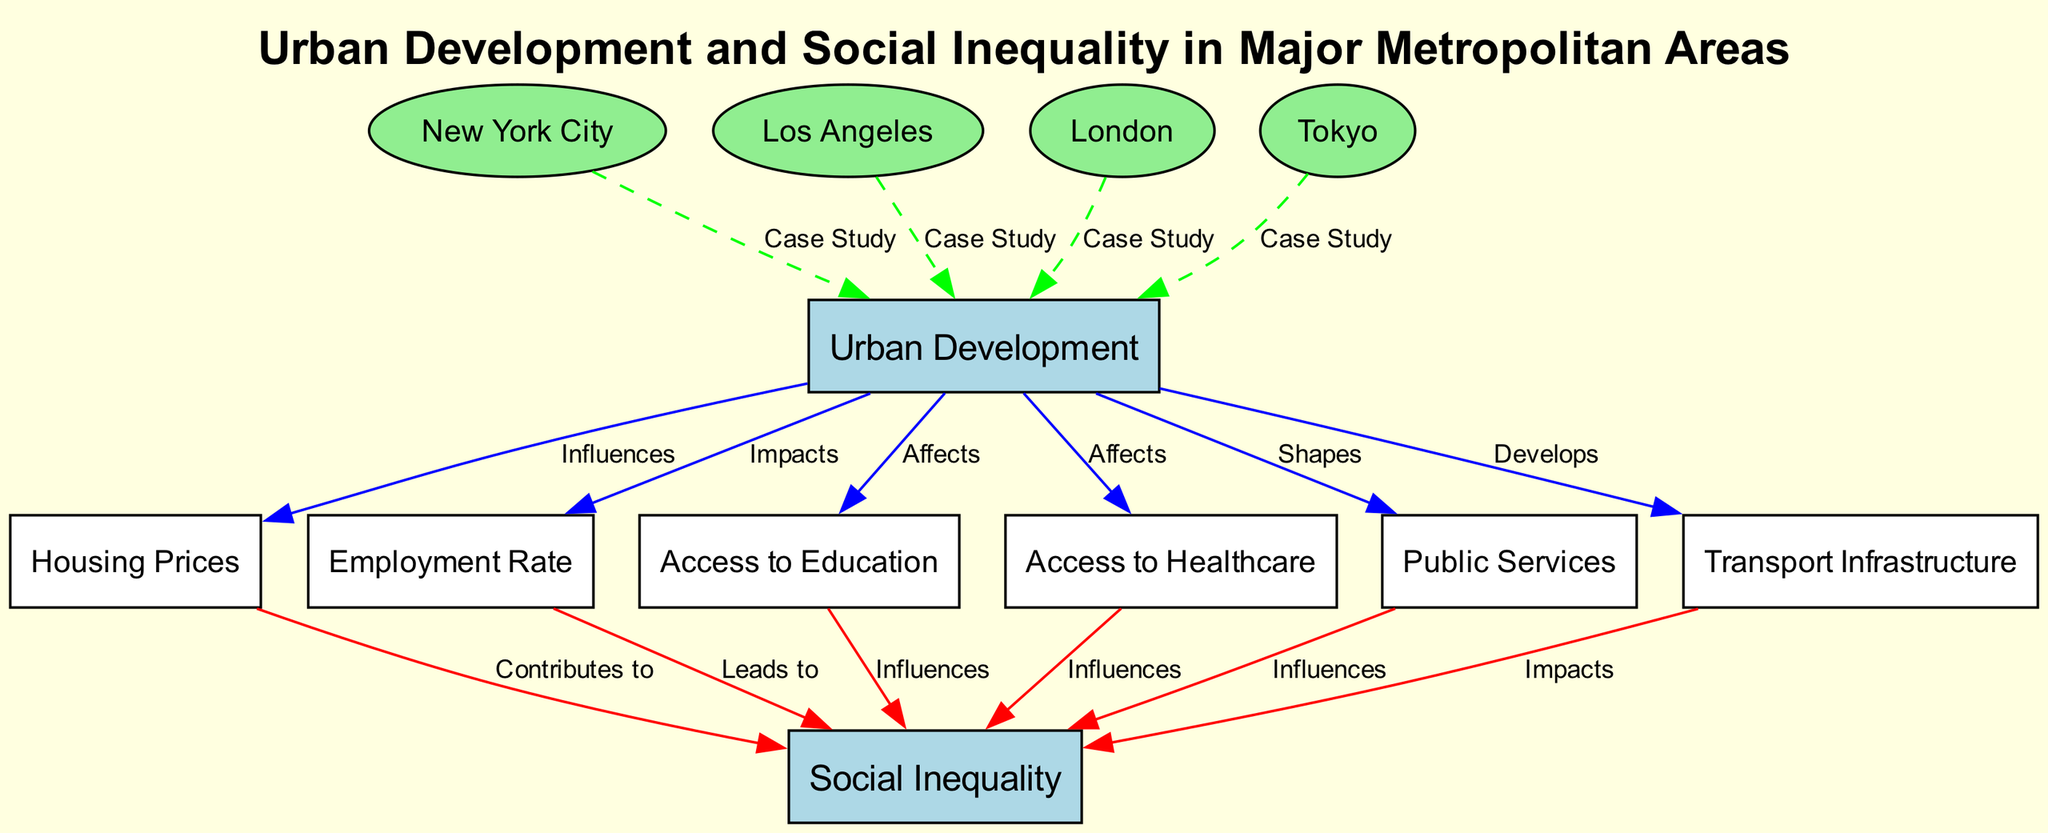What are the main nodes in the diagram? The main nodes are "Urban Development" and "Social Inequality". These are the central concepts that the diagram discusses, indicating the focus of the analysis on the relationship between urban development and its social impacts.
Answer: Urban Development, Social Inequality How many case study cities are represented? The diagram shows four case study cities: New York City, Los Angeles, London, and Tokyo. Each city is connected to the "Urban Development" node, illustrating their relevance to the study's scope.
Answer: Four Which node influences housing prices? The node "Urban Development" influences housing prices as indicated by the directed edge labeled "Influences" connecting them. This shows that the development of urban areas has an effect on the cost of housing.
Answer: Urban Development What contributes to social inequality? The node "Housing Prices" contributes to social inequality, as represented by the directed edge labeled "Contributes to." This suggests that disparities in housing prices are a factor leading to social inequality.
Answer: Housing Prices Which factors influence social inequality? The factors influencing social inequality are: "Housing Prices," "Employment Rate," "Access to Education," "Access to Healthcare," "Public Services," and "Transport Infrastructure." They all have directed edges leading to the "Social Inequality" node, indicating their influence on social disparities.
Answer: Housing Prices, Employment Rate, Access to Education, Access to Healthcare, Public Services, Transport Infrastructure How does urban development affect public services? Urban development shapes public services, as indicated by the directed edge labeled "Shapes." This means that the nature and extent of urban development have a direct impact on the availability and quality of public services in metropolitan areas.
Answer: Shapes Which metropolitan area has a direct connection to urban development? All four cities - New York City, Los Angeles, London, and Tokyo - have direct connections to "Urban Development," each receiving specific case study attention in the analysis of urban development practices.
Answer: New York City, Los Angeles, London, Tokyo What is the role of transport infrastructure in relation to social inequality? The transport infrastructure impacts social inequality, as shown by the directed edge labeled "Impacts." This indicates that the quality and accessibility of transportation options can affect social disparities in urban areas.
Answer: Impacts Does access to education affect social inequality? Yes, access to education influences social inequality, as indicated by the directed edge labeled "Influences" connecting "Access to Education" to "Social Inequality." This relationship illustrates how educational opportunities relate to social disparities.
Answer: Influences 